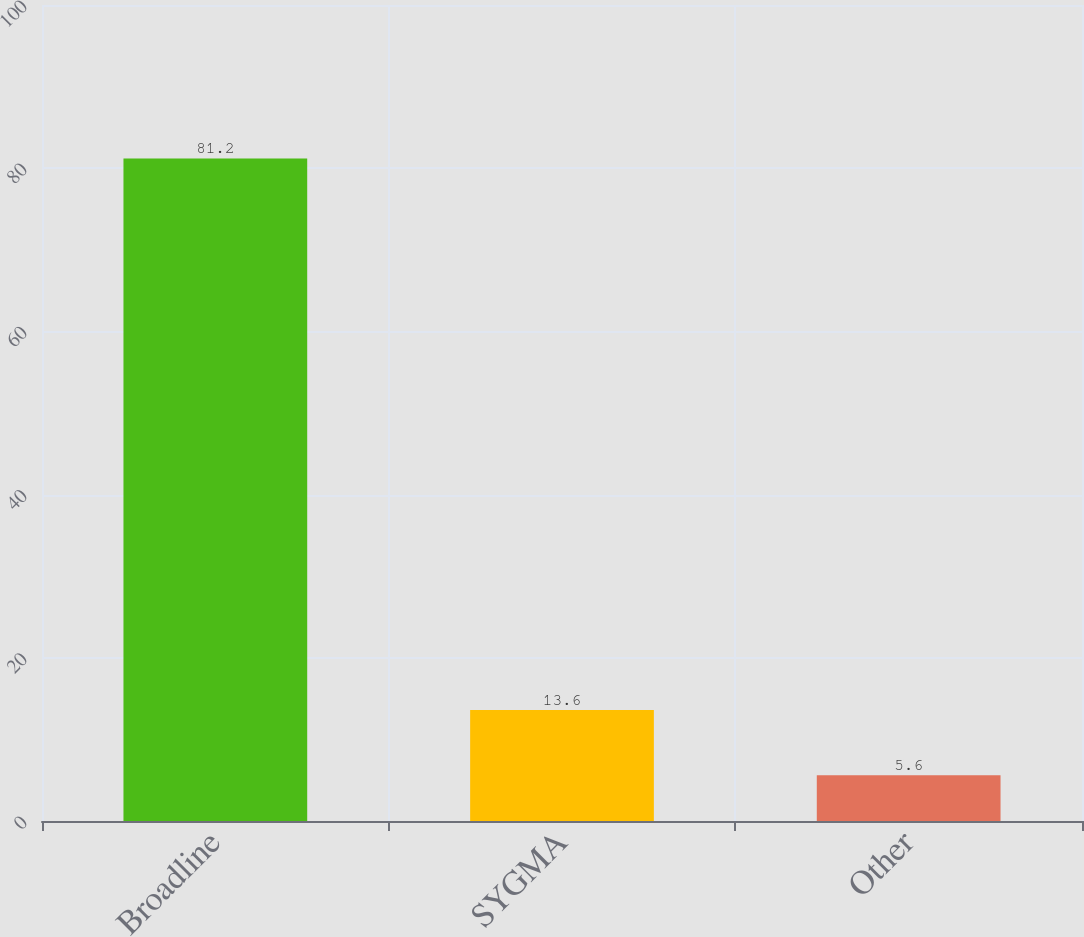Convert chart. <chart><loc_0><loc_0><loc_500><loc_500><bar_chart><fcel>Broadline<fcel>SYGMA<fcel>Other<nl><fcel>81.2<fcel>13.6<fcel>5.6<nl></chart> 